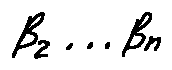Convert formula to latex. <formula><loc_0><loc_0><loc_500><loc_500>\beta _ { 2 } \dots \beta _ { n }</formula> 